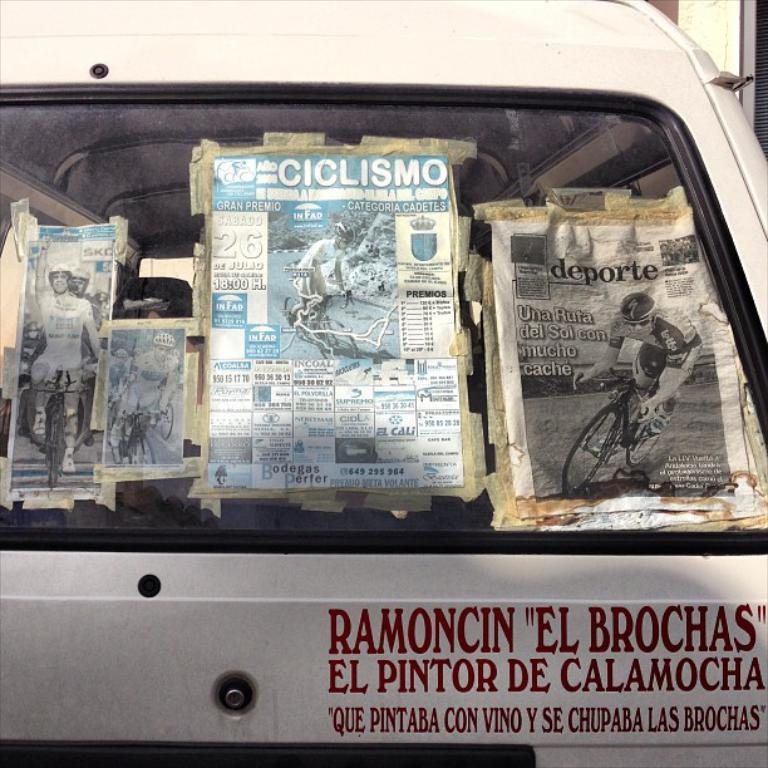What is the main object in the image? There is a vehicle in the image. What is written on the vehicle? There is text written on the vehicle. What else can be seen in the image besides the vehicle? There are papers with images and text in the image. How are the papers attached to the vehicle? The papers are pasted to the vehicle. What type of mint is growing on the road next to the vehicle in the image? There is no mint or road visible in the image; it only shows a vehicle with papers pasted on it. 